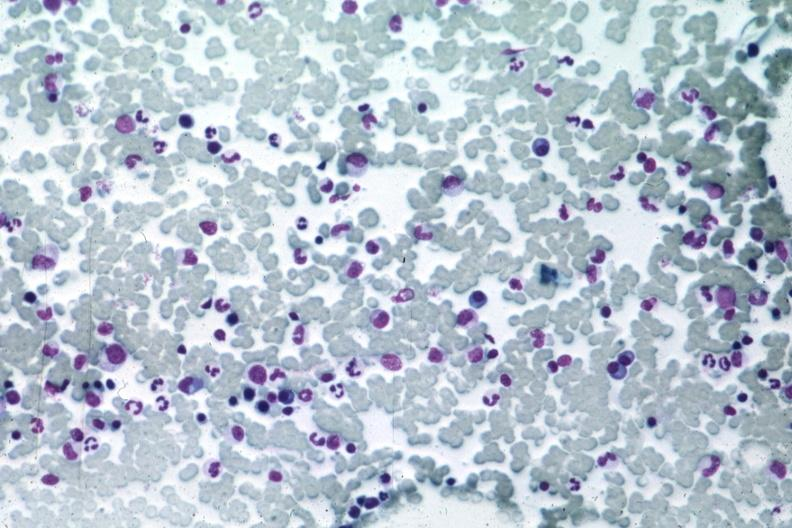what does this image show?
Answer the question using a single word or phrase. Med many atypical plasma cells easily seen 